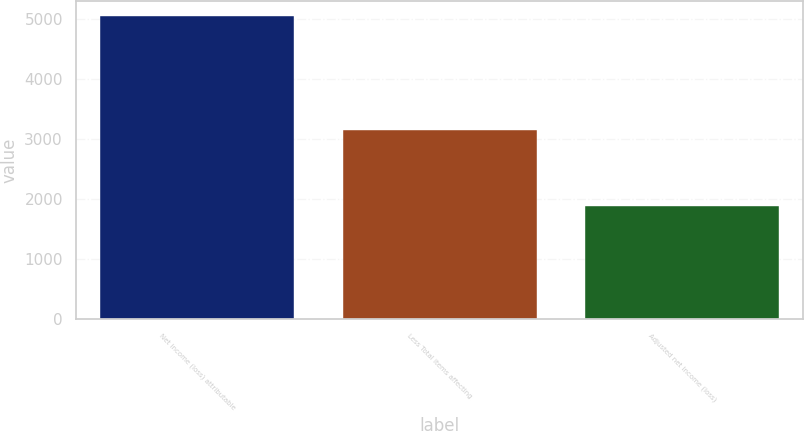Convert chart to OTSL. <chart><loc_0><loc_0><loc_500><loc_500><bar_chart><fcel>Net income (loss) attributable<fcel>Less Total items affecting<fcel>Adjusted net income (loss)<nl><fcel>5052<fcel>3160<fcel>1892<nl></chart> 